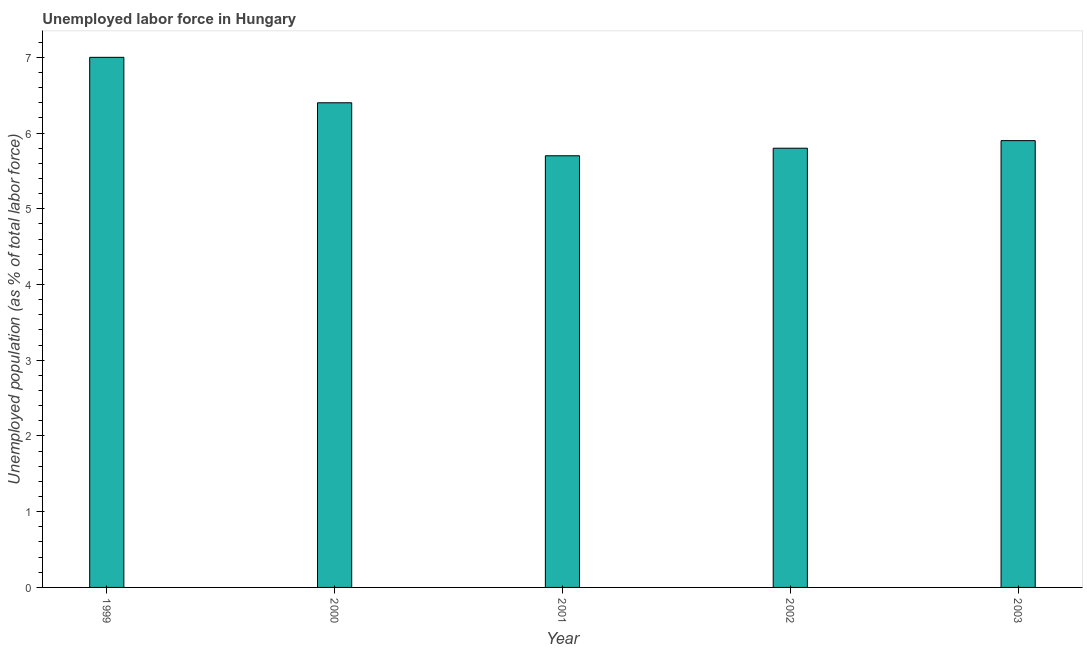What is the title of the graph?
Offer a terse response. Unemployed labor force in Hungary. What is the label or title of the Y-axis?
Make the answer very short. Unemployed population (as % of total labor force). What is the total unemployed population in 1999?
Your answer should be compact. 7. Across all years, what is the minimum total unemployed population?
Give a very brief answer. 5.7. In which year was the total unemployed population maximum?
Make the answer very short. 1999. In which year was the total unemployed population minimum?
Your response must be concise. 2001. What is the sum of the total unemployed population?
Your answer should be very brief. 30.8. What is the difference between the total unemployed population in 1999 and 2002?
Offer a terse response. 1.2. What is the average total unemployed population per year?
Offer a terse response. 6.16. What is the median total unemployed population?
Offer a terse response. 5.9. In how many years, is the total unemployed population greater than 2.6 %?
Provide a short and direct response. 5. What is the ratio of the total unemployed population in 2001 to that in 2002?
Your response must be concise. 0.98. What is the difference between the highest and the second highest total unemployed population?
Your response must be concise. 0.6. Is the sum of the total unemployed population in 1999 and 2000 greater than the maximum total unemployed population across all years?
Provide a short and direct response. Yes. How many bars are there?
Your response must be concise. 5. What is the difference between two consecutive major ticks on the Y-axis?
Your answer should be compact. 1. What is the Unemployed population (as % of total labor force) in 1999?
Your answer should be very brief. 7. What is the Unemployed population (as % of total labor force) of 2000?
Give a very brief answer. 6.4. What is the Unemployed population (as % of total labor force) in 2001?
Give a very brief answer. 5.7. What is the Unemployed population (as % of total labor force) in 2002?
Offer a terse response. 5.8. What is the Unemployed population (as % of total labor force) of 2003?
Your answer should be compact. 5.9. What is the difference between the Unemployed population (as % of total labor force) in 1999 and 2000?
Keep it short and to the point. 0.6. What is the difference between the Unemployed population (as % of total labor force) in 1999 and 2003?
Make the answer very short. 1.1. What is the difference between the Unemployed population (as % of total labor force) in 2000 and 2001?
Provide a short and direct response. 0.7. What is the difference between the Unemployed population (as % of total labor force) in 2000 and 2003?
Your answer should be compact. 0.5. What is the difference between the Unemployed population (as % of total labor force) in 2001 and 2002?
Provide a succinct answer. -0.1. What is the difference between the Unemployed population (as % of total labor force) in 2001 and 2003?
Make the answer very short. -0.2. What is the difference between the Unemployed population (as % of total labor force) in 2002 and 2003?
Offer a terse response. -0.1. What is the ratio of the Unemployed population (as % of total labor force) in 1999 to that in 2000?
Provide a succinct answer. 1.09. What is the ratio of the Unemployed population (as % of total labor force) in 1999 to that in 2001?
Offer a very short reply. 1.23. What is the ratio of the Unemployed population (as % of total labor force) in 1999 to that in 2002?
Your answer should be compact. 1.21. What is the ratio of the Unemployed population (as % of total labor force) in 1999 to that in 2003?
Offer a very short reply. 1.19. What is the ratio of the Unemployed population (as % of total labor force) in 2000 to that in 2001?
Keep it short and to the point. 1.12. What is the ratio of the Unemployed population (as % of total labor force) in 2000 to that in 2002?
Offer a terse response. 1.1. What is the ratio of the Unemployed population (as % of total labor force) in 2000 to that in 2003?
Keep it short and to the point. 1.08. What is the ratio of the Unemployed population (as % of total labor force) in 2002 to that in 2003?
Provide a short and direct response. 0.98. 